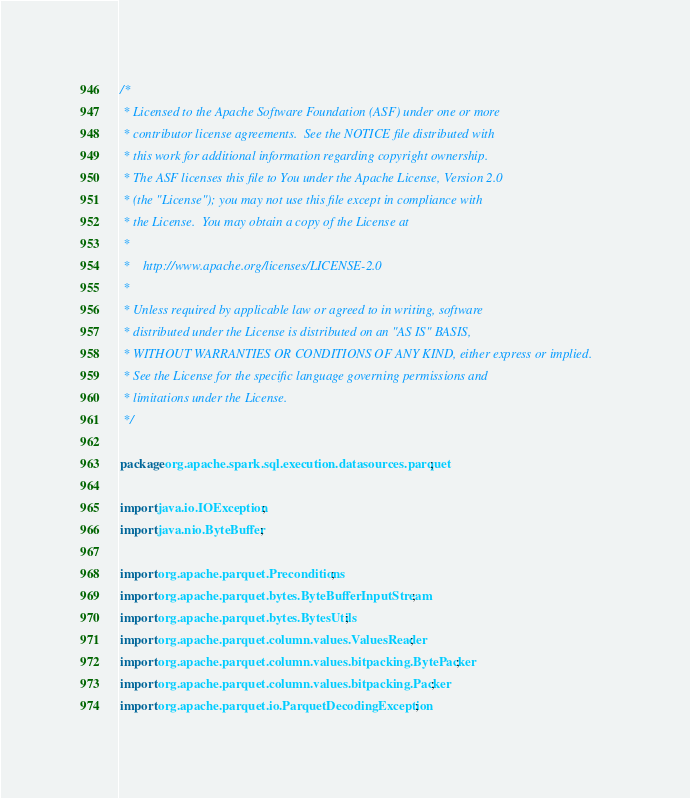<code> <loc_0><loc_0><loc_500><loc_500><_Java_>/*
 * Licensed to the Apache Software Foundation (ASF) under one or more
 * contributor license agreements.  See the NOTICE file distributed with
 * this work for additional information regarding copyright ownership.
 * The ASF licenses this file to You under the Apache License, Version 2.0
 * (the "License"); you may not use this file except in compliance with
 * the License.  You may obtain a copy of the License at
 *
 *    http://www.apache.org/licenses/LICENSE-2.0
 *
 * Unless required by applicable law or agreed to in writing, software
 * distributed under the License is distributed on an "AS IS" BASIS,
 * WITHOUT WARRANTIES OR CONDITIONS OF ANY KIND, either express or implied.
 * See the License for the specific language governing permissions and
 * limitations under the License.
 */

package org.apache.spark.sql.execution.datasources.parquet;

import java.io.IOException;
import java.nio.ByteBuffer;

import org.apache.parquet.Preconditions;
import org.apache.parquet.bytes.ByteBufferInputStream;
import org.apache.parquet.bytes.BytesUtils;
import org.apache.parquet.column.values.ValuesReader;
import org.apache.parquet.column.values.bitpacking.BytePacker;
import org.apache.parquet.column.values.bitpacking.Packer;
import org.apache.parquet.io.ParquetDecodingException;</code> 